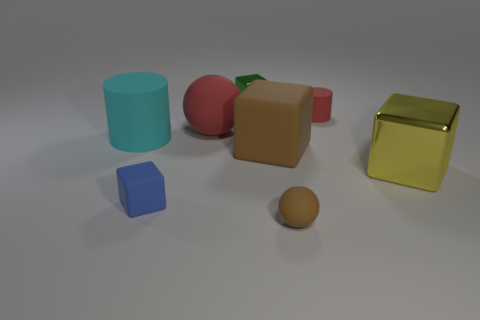Are there fewer brown blocks that are in front of the small rubber ball than brown cubes on the right side of the large yellow cube?
Your answer should be compact. No. What is the color of the large shiny object that is the same shape as the large brown matte thing?
Your response must be concise. Yellow. What size is the red matte sphere?
Ensure brevity in your answer.  Large. How many cyan metallic spheres have the same size as the yellow shiny thing?
Your answer should be very brief. 0. Does the large metallic cube have the same color as the tiny cylinder?
Make the answer very short. No. Is the sphere in front of the big matte cylinder made of the same material as the small block that is to the left of the green shiny cube?
Offer a very short reply. Yes. Is the number of small red matte things greater than the number of big purple spheres?
Offer a very short reply. Yes. Are there any other things that have the same color as the small matte block?
Provide a succinct answer. No. Does the large yellow cube have the same material as the brown block?
Give a very brief answer. No. Is the number of red rubber spheres less than the number of large yellow rubber spheres?
Keep it short and to the point. No. 